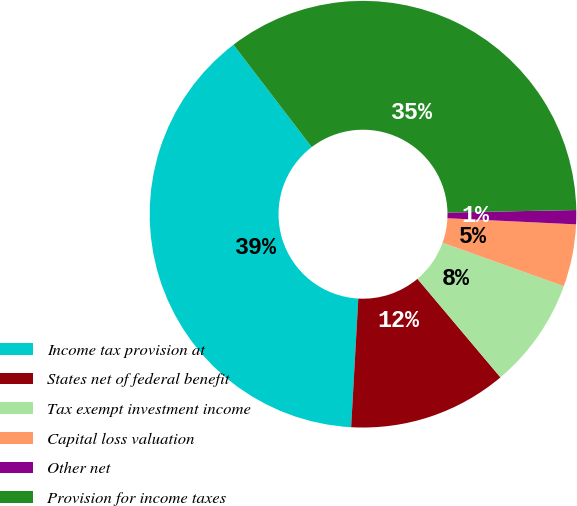Convert chart. <chart><loc_0><loc_0><loc_500><loc_500><pie_chart><fcel>Income tax provision at<fcel>States net of federal benefit<fcel>Tax exempt investment income<fcel>Capital loss valuation<fcel>Other net<fcel>Provision for income taxes<nl><fcel>38.73%<fcel>12.03%<fcel>8.38%<fcel>4.72%<fcel>1.07%<fcel>35.08%<nl></chart> 